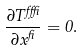Convert formula to latex. <formula><loc_0><loc_0><loc_500><loc_500>\frac { \partial T ^ { \alpha \beta } } { \partial x ^ { \beta } } = 0 .</formula> 